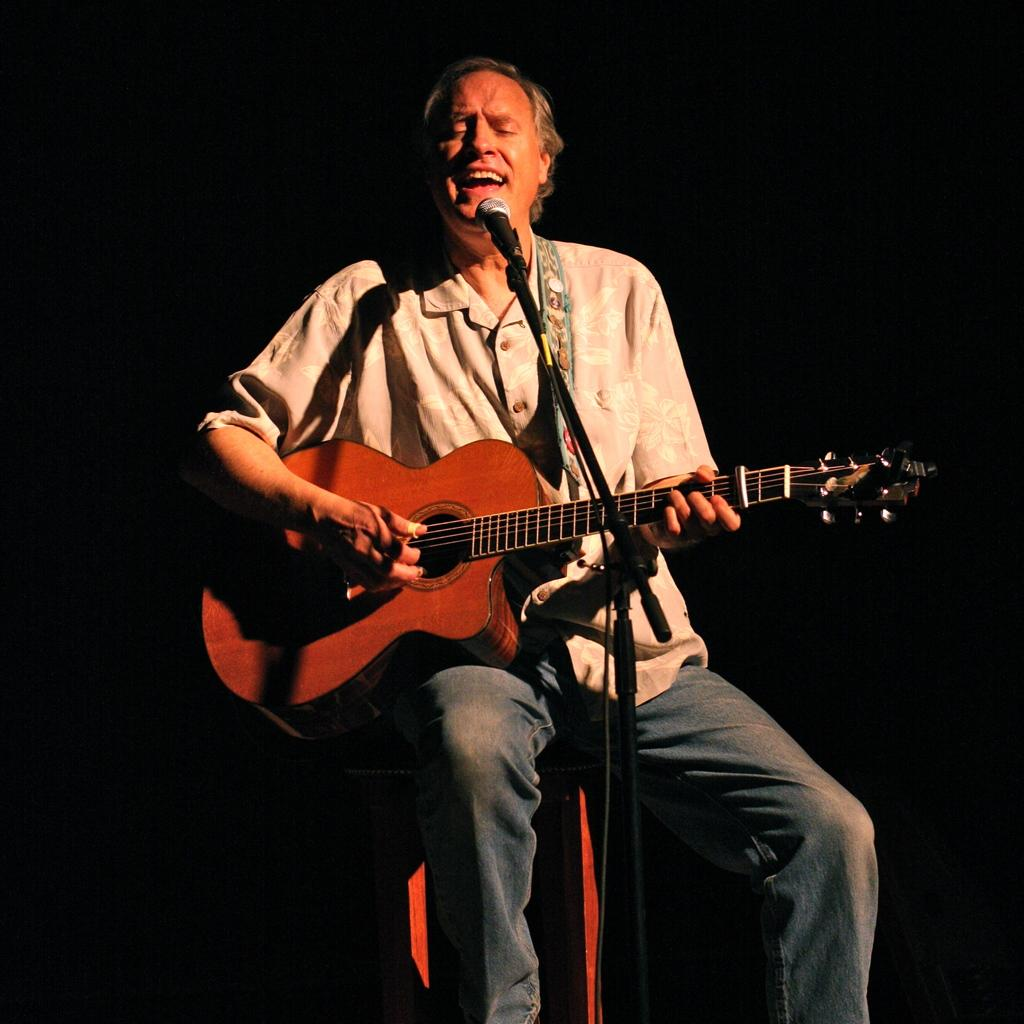Who is the main subject in the image? There is a man in the image. What is the man doing in the image? The man is sitting in the image. What object is the man holding? The man is holding a guitar in the image. What is the purpose of the microphone in front of the man? The microphone is likely used for amplifying the man's voice or guitar playing. What type of food is the man eating in the image? There is no food present in the image; the man is holding a guitar and sitting near a microphone. 